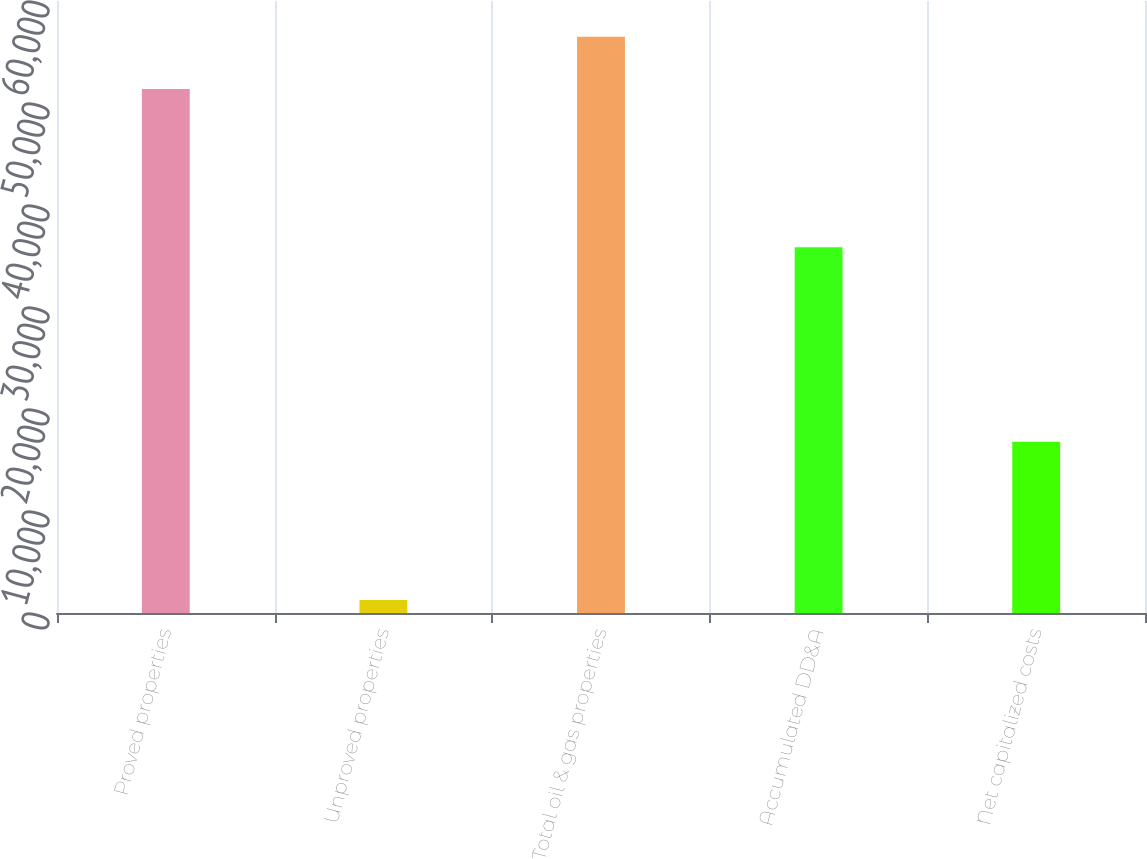Convert chart. <chart><loc_0><loc_0><loc_500><loc_500><bar_chart><fcel>Proved properties<fcel>Unproved properties<fcel>Total oil & gas properties<fcel>Accumulated DD&A<fcel>Net capitalized costs<nl><fcel>51366<fcel>1277<fcel>56502.6<fcel>35848<fcel>16795<nl></chart> 